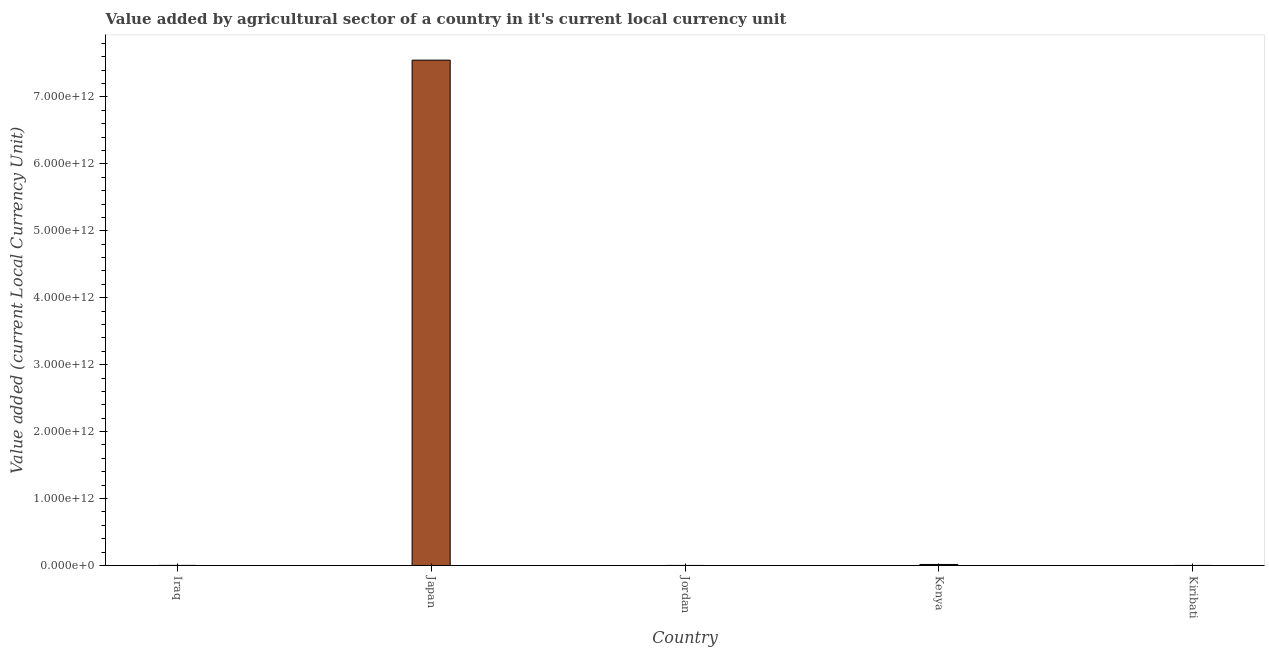Does the graph contain any zero values?
Offer a very short reply. No. What is the title of the graph?
Your answer should be compact. Value added by agricultural sector of a country in it's current local currency unit. What is the label or title of the Y-axis?
Make the answer very short. Value added (current Local Currency Unit). What is the value added by agriculture sector in Jordan?
Offer a terse response. 8.32e+07. Across all countries, what is the maximum value added by agriculture sector?
Your response must be concise. 7.55e+12. Across all countries, what is the minimum value added by agriculture sector?
Your response must be concise. 4.86e+06. In which country was the value added by agriculture sector minimum?
Offer a terse response. Kiribati. What is the sum of the value added by agriculture sector?
Your response must be concise. 7.57e+12. What is the difference between the value added by agriculture sector in Iraq and Jordan?
Provide a succinct answer. 6.59e+08. What is the average value added by agriculture sector per country?
Provide a short and direct response. 1.51e+12. What is the median value added by agriculture sector?
Offer a terse response. 7.42e+08. What is the ratio of the value added by agriculture sector in Jordan to that in Kenya?
Provide a short and direct response. 0.01. What is the difference between the highest and the second highest value added by agriculture sector?
Make the answer very short. 7.54e+12. Is the sum of the value added by agriculture sector in Jordan and Kenya greater than the maximum value added by agriculture sector across all countries?
Offer a terse response. No. What is the difference between the highest and the lowest value added by agriculture sector?
Keep it short and to the point. 7.55e+12. What is the difference between two consecutive major ticks on the Y-axis?
Provide a succinct answer. 1.00e+12. What is the Value added (current Local Currency Unit) in Iraq?
Provide a short and direct response. 7.42e+08. What is the Value added (current Local Currency Unit) in Japan?
Give a very brief answer. 7.55e+12. What is the Value added (current Local Currency Unit) of Jordan?
Your response must be concise. 8.32e+07. What is the Value added (current Local Currency Unit) in Kenya?
Give a very brief answer. 1.50e+1. What is the Value added (current Local Currency Unit) in Kiribati?
Your answer should be compact. 4.86e+06. What is the difference between the Value added (current Local Currency Unit) in Iraq and Japan?
Offer a terse response. -7.55e+12. What is the difference between the Value added (current Local Currency Unit) in Iraq and Jordan?
Provide a short and direct response. 6.59e+08. What is the difference between the Value added (current Local Currency Unit) in Iraq and Kenya?
Offer a terse response. -1.42e+1. What is the difference between the Value added (current Local Currency Unit) in Iraq and Kiribati?
Provide a short and direct response. 7.37e+08. What is the difference between the Value added (current Local Currency Unit) in Japan and Jordan?
Keep it short and to the point. 7.55e+12. What is the difference between the Value added (current Local Currency Unit) in Japan and Kenya?
Make the answer very short. 7.54e+12. What is the difference between the Value added (current Local Currency Unit) in Japan and Kiribati?
Provide a short and direct response. 7.55e+12. What is the difference between the Value added (current Local Currency Unit) in Jordan and Kenya?
Your answer should be compact. -1.49e+1. What is the difference between the Value added (current Local Currency Unit) in Jordan and Kiribati?
Provide a short and direct response. 7.83e+07. What is the difference between the Value added (current Local Currency Unit) in Kenya and Kiribati?
Provide a succinct answer. 1.50e+1. What is the ratio of the Value added (current Local Currency Unit) in Iraq to that in Japan?
Offer a very short reply. 0. What is the ratio of the Value added (current Local Currency Unit) in Iraq to that in Jordan?
Offer a terse response. 8.92. What is the ratio of the Value added (current Local Currency Unit) in Iraq to that in Kenya?
Provide a short and direct response. 0.05. What is the ratio of the Value added (current Local Currency Unit) in Iraq to that in Kiribati?
Offer a terse response. 152.65. What is the ratio of the Value added (current Local Currency Unit) in Japan to that in Jordan?
Make the answer very short. 9.07e+04. What is the ratio of the Value added (current Local Currency Unit) in Japan to that in Kenya?
Your answer should be compact. 503.94. What is the ratio of the Value added (current Local Currency Unit) in Japan to that in Kiribati?
Offer a terse response. 1.55e+06. What is the ratio of the Value added (current Local Currency Unit) in Jordan to that in Kenya?
Offer a terse response. 0.01. What is the ratio of the Value added (current Local Currency Unit) in Jordan to that in Kiribati?
Offer a very short reply. 17.12. What is the ratio of the Value added (current Local Currency Unit) in Kenya to that in Kiribati?
Keep it short and to the point. 3082.72. 